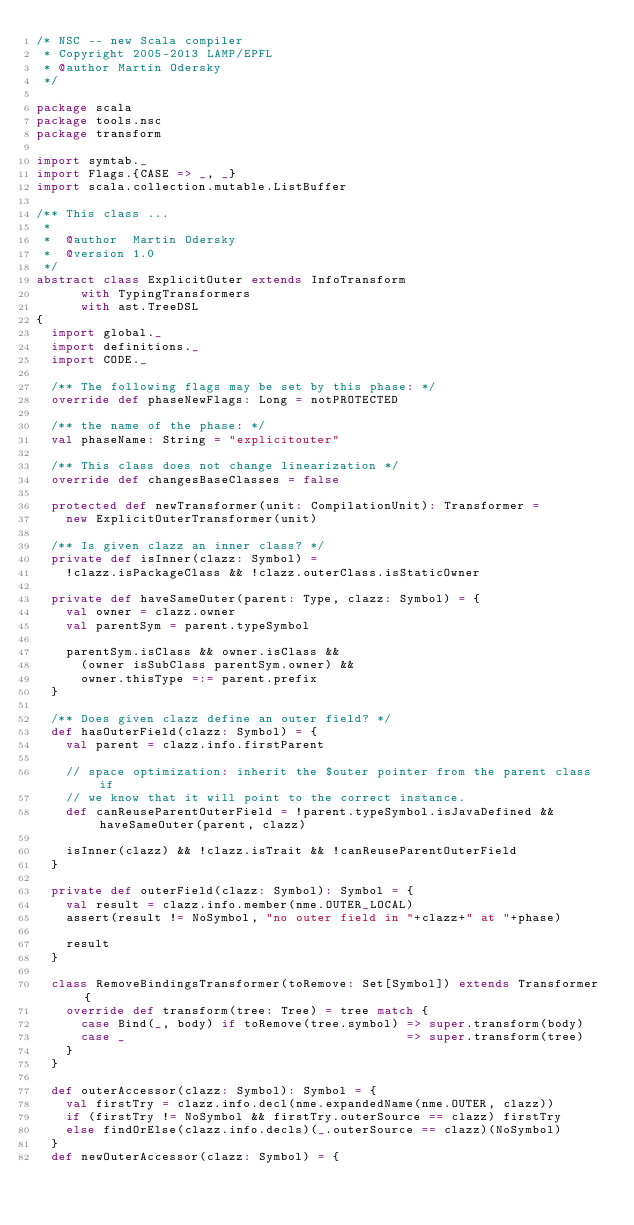<code> <loc_0><loc_0><loc_500><loc_500><_Scala_>/* NSC -- new Scala compiler
 * Copyright 2005-2013 LAMP/EPFL
 * @author Martin Odersky
 */

package scala
package tools.nsc
package transform

import symtab._
import Flags.{CASE => _, _}
import scala.collection.mutable.ListBuffer

/** This class ...
 *
 *  @author  Martin Odersky
 *  @version 1.0
 */
abstract class ExplicitOuter extends InfoTransform
      with TypingTransformers
      with ast.TreeDSL
{
  import global._
  import definitions._
  import CODE._

  /** The following flags may be set by this phase: */
  override def phaseNewFlags: Long = notPROTECTED

  /** the name of the phase: */
  val phaseName: String = "explicitouter"

  /** This class does not change linearization */
  override def changesBaseClasses = false

  protected def newTransformer(unit: CompilationUnit): Transformer =
    new ExplicitOuterTransformer(unit)

  /** Is given clazz an inner class? */
  private def isInner(clazz: Symbol) =
    !clazz.isPackageClass && !clazz.outerClass.isStaticOwner

  private def haveSameOuter(parent: Type, clazz: Symbol) = {
    val owner = clazz.owner
    val parentSym = parent.typeSymbol

    parentSym.isClass && owner.isClass &&
      (owner isSubClass parentSym.owner) &&
      owner.thisType =:= parent.prefix
  }

  /** Does given clazz define an outer field? */
  def hasOuterField(clazz: Symbol) = {
    val parent = clazz.info.firstParent

    // space optimization: inherit the $outer pointer from the parent class if
    // we know that it will point to the correct instance.
    def canReuseParentOuterField = !parent.typeSymbol.isJavaDefined && haveSameOuter(parent, clazz)

    isInner(clazz) && !clazz.isTrait && !canReuseParentOuterField
  }

  private def outerField(clazz: Symbol): Symbol = {
    val result = clazz.info.member(nme.OUTER_LOCAL)
    assert(result != NoSymbol, "no outer field in "+clazz+" at "+phase)

    result
  }

  class RemoveBindingsTransformer(toRemove: Set[Symbol]) extends Transformer {
    override def transform(tree: Tree) = tree match {
      case Bind(_, body) if toRemove(tree.symbol) => super.transform(body)
      case _                                      => super.transform(tree)
    }
  }

  def outerAccessor(clazz: Symbol): Symbol = {
    val firstTry = clazz.info.decl(nme.expandedName(nme.OUTER, clazz))
    if (firstTry != NoSymbol && firstTry.outerSource == clazz) firstTry
    else findOrElse(clazz.info.decls)(_.outerSource == clazz)(NoSymbol)
  }
  def newOuterAccessor(clazz: Symbol) = {</code> 